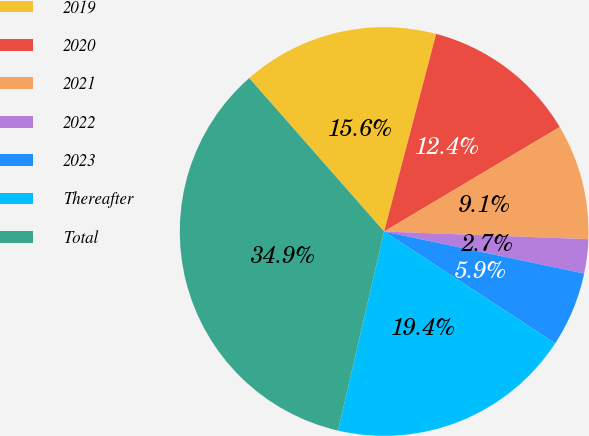Convert chart to OTSL. <chart><loc_0><loc_0><loc_500><loc_500><pie_chart><fcel>2019<fcel>2020<fcel>2021<fcel>2022<fcel>2023<fcel>Thereafter<fcel>Total<nl><fcel>15.58%<fcel>12.36%<fcel>9.14%<fcel>2.7%<fcel>5.92%<fcel>19.41%<fcel>34.9%<nl></chart> 